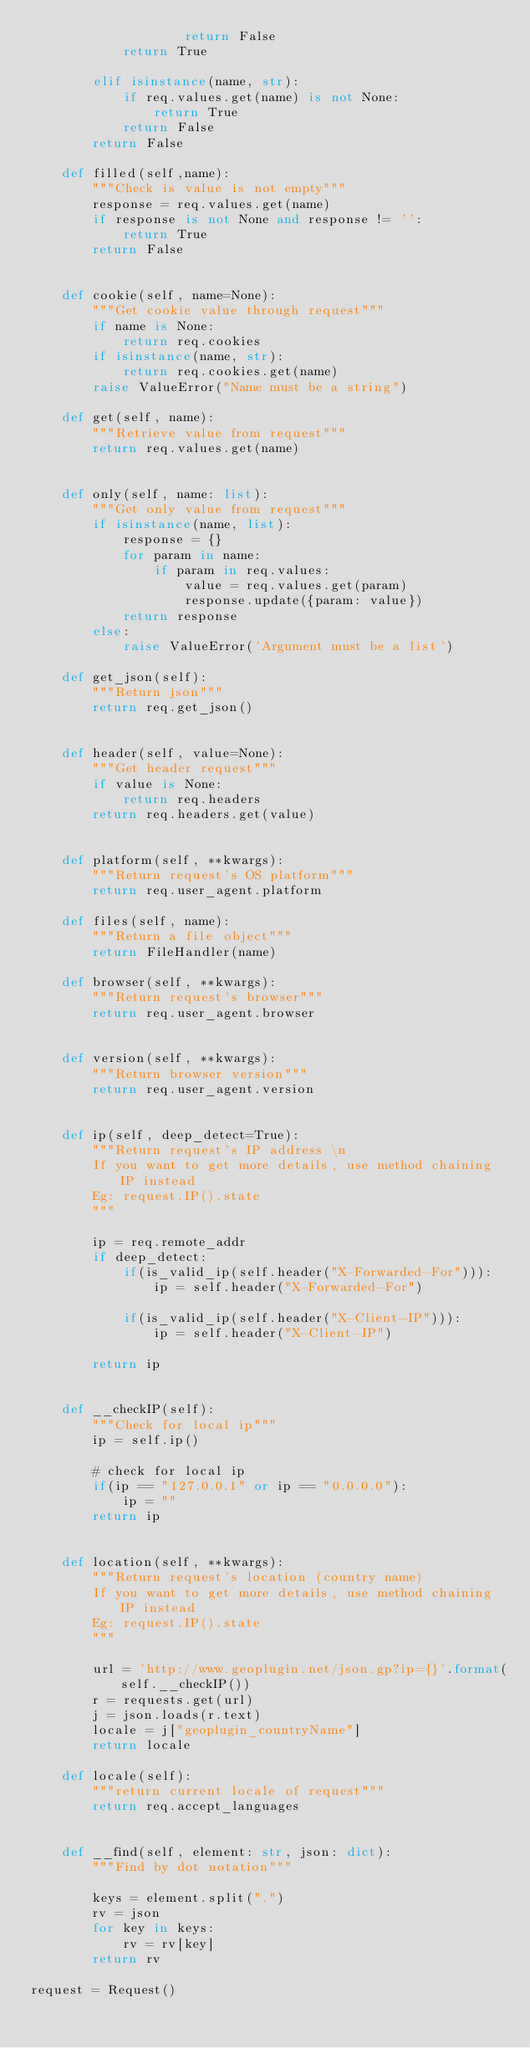<code> <loc_0><loc_0><loc_500><loc_500><_Python_>                    return False
            return True

        elif isinstance(name, str):
            if req.values.get(name) is not None:
                return True
            return False
        return False
    
    def filled(self,name):
        """Check is value is not empty"""
        response = req.values.get(name)
        if response is not None and response != '':
            return True
        return False

   
    def cookie(self, name=None):
        """Get cookie value through request"""
        if name is None:
            return req.cookies
        if isinstance(name, str):
            return req.cookies.get(name)
        raise ValueError("Name must be a string")
    
    def get(self, name):
        """Retrieve value from request"""
        return req.values.get(name)
    
        
    def only(self, name: list):
        """Get only value from request"""
        if isinstance(name, list):
            response = {}
            for param in name:
                if param in req.values:
                    value = req.values.get(param)
                    response.update({param: value})
            return response
        else:
            raise ValueError('Argument must be a list')

    def get_json(self):
        """Return json"""
        return req.get_json()
    

    def header(self, value=None):
        """Get header request"""
        if value is None:
            return req.headers
        return req.headers.get(value)


    def platform(self, **kwargs):
        """Return request's OS platform"""
        return req.user_agent.platform
    
    def files(self, name):
        """Return a file object"""
        return FileHandler(name)
    
    def browser(self, **kwargs):
        """Return request's browser"""
        return req.user_agent.browser
    

    def version(self, **kwargs):
        """Return browser version"""
        return req.user_agent.version


    def ip(self, deep_detect=True):
        """Return request's IP address \n
        If you want to get more details, use method chaining IP instead
        Eg: request.IP().state
        """

        ip = req.remote_addr
        if deep_detect:
            if(is_valid_ip(self.header("X-Forwarded-For"))):
                ip = self.header("X-Forwarded-For")

            if(is_valid_ip(self.header("X-Client-IP"))):
                ip = self.header("X-Client-IP")

        return ip


    def __checkIP(self):
        """Check for local ip"""
        ip = self.ip()

        # check for local ip
        if(ip == "127.0.0.1" or ip == "0.0.0.0"):
            ip = ""
        return ip


    def location(self, **kwargs):
        """Return request's location (country name)
        If you want to get more details, use method chaining IP instead
        Eg: request.IP().state
        """
        
        url = 'http://www.geoplugin.net/json.gp?ip={}'.format(self.__checkIP())
        r = requests.get(url)
        j = json.loads(r.text)
        locale = j["geoplugin_countryName"]
        return locale
    
    def locale(self):
        """return current locale of request"""
        return req.accept_languages
    

    def __find(self, element: str, json: dict):
        """Find by dot notation"""

        keys = element.split(".")
        rv = json
        for key in keys:
            rv = rv[key]
        return rv

request = Request()</code> 